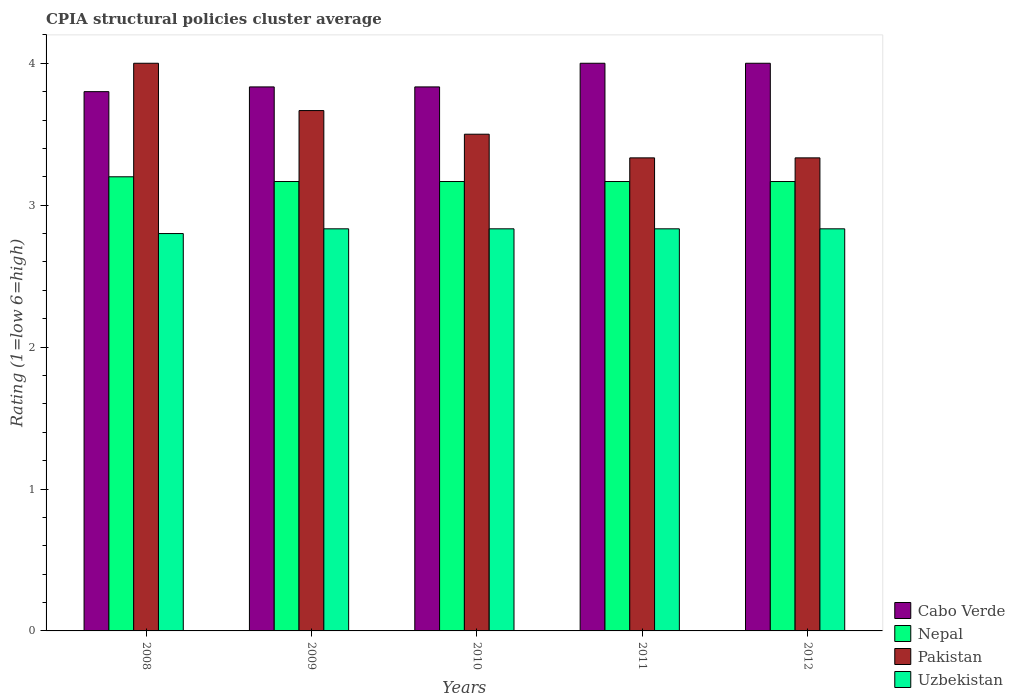How many different coloured bars are there?
Ensure brevity in your answer.  4. How many groups of bars are there?
Offer a terse response. 5. Are the number of bars per tick equal to the number of legend labels?
Keep it short and to the point. Yes. How many bars are there on the 5th tick from the right?
Give a very brief answer. 4. What is the CPIA rating in Uzbekistan in 2008?
Offer a very short reply. 2.8. Across all years, what is the maximum CPIA rating in Uzbekistan?
Ensure brevity in your answer.  2.83. Across all years, what is the minimum CPIA rating in Nepal?
Offer a very short reply. 3.17. In which year was the CPIA rating in Uzbekistan minimum?
Your answer should be compact. 2008. What is the total CPIA rating in Nepal in the graph?
Keep it short and to the point. 15.87. What is the difference between the CPIA rating in Pakistan in 2008 and the CPIA rating in Uzbekistan in 2011?
Keep it short and to the point. 1.17. What is the average CPIA rating in Nepal per year?
Give a very brief answer. 3.17. In the year 2012, what is the difference between the CPIA rating in Nepal and CPIA rating in Cabo Verde?
Offer a very short reply. -0.83. In how many years, is the CPIA rating in Pakistan greater than 0.2?
Give a very brief answer. 5. What is the ratio of the CPIA rating in Pakistan in 2008 to that in 2012?
Offer a very short reply. 1.2. Is the difference between the CPIA rating in Nepal in 2009 and 2011 greater than the difference between the CPIA rating in Cabo Verde in 2009 and 2011?
Offer a very short reply. Yes. What is the difference between the highest and the second highest CPIA rating in Nepal?
Make the answer very short. 0.03. What is the difference between the highest and the lowest CPIA rating in Pakistan?
Make the answer very short. 0.67. In how many years, is the CPIA rating in Nepal greater than the average CPIA rating in Nepal taken over all years?
Offer a very short reply. 1. Is it the case that in every year, the sum of the CPIA rating in Nepal and CPIA rating in Cabo Verde is greater than the sum of CPIA rating in Pakistan and CPIA rating in Uzbekistan?
Offer a terse response. No. What does the 4th bar from the left in 2009 represents?
Offer a very short reply. Uzbekistan. What does the 4th bar from the right in 2010 represents?
Your answer should be compact. Cabo Verde. Are all the bars in the graph horizontal?
Your answer should be compact. No. What is the difference between two consecutive major ticks on the Y-axis?
Keep it short and to the point. 1. Are the values on the major ticks of Y-axis written in scientific E-notation?
Your answer should be very brief. No. Does the graph contain grids?
Provide a short and direct response. No. Where does the legend appear in the graph?
Offer a terse response. Bottom right. How many legend labels are there?
Keep it short and to the point. 4. How are the legend labels stacked?
Provide a succinct answer. Vertical. What is the title of the graph?
Keep it short and to the point. CPIA structural policies cluster average. What is the Rating (1=low 6=high) of Pakistan in 2008?
Provide a succinct answer. 4. What is the Rating (1=low 6=high) of Cabo Verde in 2009?
Provide a short and direct response. 3.83. What is the Rating (1=low 6=high) in Nepal in 2009?
Keep it short and to the point. 3.17. What is the Rating (1=low 6=high) of Pakistan in 2009?
Ensure brevity in your answer.  3.67. What is the Rating (1=low 6=high) in Uzbekistan in 2009?
Provide a short and direct response. 2.83. What is the Rating (1=low 6=high) in Cabo Verde in 2010?
Keep it short and to the point. 3.83. What is the Rating (1=low 6=high) of Nepal in 2010?
Provide a succinct answer. 3.17. What is the Rating (1=low 6=high) in Uzbekistan in 2010?
Offer a terse response. 2.83. What is the Rating (1=low 6=high) in Nepal in 2011?
Keep it short and to the point. 3.17. What is the Rating (1=low 6=high) of Pakistan in 2011?
Ensure brevity in your answer.  3.33. What is the Rating (1=low 6=high) of Uzbekistan in 2011?
Offer a very short reply. 2.83. What is the Rating (1=low 6=high) of Nepal in 2012?
Make the answer very short. 3.17. What is the Rating (1=low 6=high) in Pakistan in 2012?
Offer a terse response. 3.33. What is the Rating (1=low 6=high) in Uzbekistan in 2012?
Make the answer very short. 2.83. Across all years, what is the maximum Rating (1=low 6=high) of Pakistan?
Your answer should be very brief. 4. Across all years, what is the maximum Rating (1=low 6=high) of Uzbekistan?
Provide a succinct answer. 2.83. Across all years, what is the minimum Rating (1=low 6=high) of Nepal?
Provide a short and direct response. 3.17. Across all years, what is the minimum Rating (1=low 6=high) of Pakistan?
Your answer should be very brief. 3.33. What is the total Rating (1=low 6=high) of Cabo Verde in the graph?
Keep it short and to the point. 19.47. What is the total Rating (1=low 6=high) in Nepal in the graph?
Keep it short and to the point. 15.87. What is the total Rating (1=low 6=high) of Pakistan in the graph?
Your answer should be compact. 17.83. What is the total Rating (1=low 6=high) of Uzbekistan in the graph?
Keep it short and to the point. 14.13. What is the difference between the Rating (1=low 6=high) in Cabo Verde in 2008 and that in 2009?
Offer a very short reply. -0.03. What is the difference between the Rating (1=low 6=high) in Nepal in 2008 and that in 2009?
Offer a terse response. 0.03. What is the difference between the Rating (1=low 6=high) of Pakistan in 2008 and that in 2009?
Provide a succinct answer. 0.33. What is the difference between the Rating (1=low 6=high) of Uzbekistan in 2008 and that in 2009?
Provide a short and direct response. -0.03. What is the difference between the Rating (1=low 6=high) of Cabo Verde in 2008 and that in 2010?
Provide a short and direct response. -0.03. What is the difference between the Rating (1=low 6=high) in Nepal in 2008 and that in 2010?
Your answer should be very brief. 0.03. What is the difference between the Rating (1=low 6=high) in Pakistan in 2008 and that in 2010?
Your response must be concise. 0.5. What is the difference between the Rating (1=low 6=high) in Uzbekistan in 2008 and that in 2010?
Make the answer very short. -0.03. What is the difference between the Rating (1=low 6=high) of Cabo Verde in 2008 and that in 2011?
Provide a succinct answer. -0.2. What is the difference between the Rating (1=low 6=high) of Uzbekistan in 2008 and that in 2011?
Make the answer very short. -0.03. What is the difference between the Rating (1=low 6=high) in Uzbekistan in 2008 and that in 2012?
Give a very brief answer. -0.03. What is the difference between the Rating (1=low 6=high) of Cabo Verde in 2009 and that in 2010?
Your response must be concise. 0. What is the difference between the Rating (1=low 6=high) of Pakistan in 2009 and that in 2010?
Your answer should be very brief. 0.17. What is the difference between the Rating (1=low 6=high) of Cabo Verde in 2009 and that in 2011?
Make the answer very short. -0.17. What is the difference between the Rating (1=low 6=high) of Nepal in 2009 and that in 2011?
Offer a terse response. 0. What is the difference between the Rating (1=low 6=high) in Uzbekistan in 2009 and that in 2011?
Your answer should be very brief. 0. What is the difference between the Rating (1=low 6=high) of Uzbekistan in 2009 and that in 2012?
Your answer should be compact. 0. What is the difference between the Rating (1=low 6=high) of Cabo Verde in 2010 and that in 2011?
Your answer should be compact. -0.17. What is the difference between the Rating (1=low 6=high) in Nepal in 2010 and that in 2011?
Make the answer very short. 0. What is the difference between the Rating (1=low 6=high) of Nepal in 2010 and that in 2012?
Ensure brevity in your answer.  0. What is the difference between the Rating (1=low 6=high) in Uzbekistan in 2011 and that in 2012?
Your answer should be very brief. 0. What is the difference between the Rating (1=low 6=high) in Cabo Verde in 2008 and the Rating (1=low 6=high) in Nepal in 2009?
Your answer should be very brief. 0.63. What is the difference between the Rating (1=low 6=high) of Cabo Verde in 2008 and the Rating (1=low 6=high) of Pakistan in 2009?
Offer a very short reply. 0.13. What is the difference between the Rating (1=low 6=high) of Cabo Verde in 2008 and the Rating (1=low 6=high) of Uzbekistan in 2009?
Your answer should be very brief. 0.97. What is the difference between the Rating (1=low 6=high) of Nepal in 2008 and the Rating (1=low 6=high) of Pakistan in 2009?
Provide a succinct answer. -0.47. What is the difference between the Rating (1=low 6=high) in Nepal in 2008 and the Rating (1=low 6=high) in Uzbekistan in 2009?
Offer a terse response. 0.37. What is the difference between the Rating (1=low 6=high) in Cabo Verde in 2008 and the Rating (1=low 6=high) in Nepal in 2010?
Provide a short and direct response. 0.63. What is the difference between the Rating (1=low 6=high) of Cabo Verde in 2008 and the Rating (1=low 6=high) of Uzbekistan in 2010?
Give a very brief answer. 0.97. What is the difference between the Rating (1=low 6=high) of Nepal in 2008 and the Rating (1=low 6=high) of Pakistan in 2010?
Keep it short and to the point. -0.3. What is the difference between the Rating (1=low 6=high) of Nepal in 2008 and the Rating (1=low 6=high) of Uzbekistan in 2010?
Provide a short and direct response. 0.37. What is the difference between the Rating (1=low 6=high) of Pakistan in 2008 and the Rating (1=low 6=high) of Uzbekistan in 2010?
Provide a short and direct response. 1.17. What is the difference between the Rating (1=low 6=high) in Cabo Verde in 2008 and the Rating (1=low 6=high) in Nepal in 2011?
Ensure brevity in your answer.  0.63. What is the difference between the Rating (1=low 6=high) of Cabo Verde in 2008 and the Rating (1=low 6=high) of Pakistan in 2011?
Provide a short and direct response. 0.47. What is the difference between the Rating (1=low 6=high) in Cabo Verde in 2008 and the Rating (1=low 6=high) in Uzbekistan in 2011?
Your answer should be very brief. 0.97. What is the difference between the Rating (1=low 6=high) of Nepal in 2008 and the Rating (1=low 6=high) of Pakistan in 2011?
Your answer should be very brief. -0.13. What is the difference between the Rating (1=low 6=high) in Nepal in 2008 and the Rating (1=low 6=high) in Uzbekistan in 2011?
Your answer should be very brief. 0.37. What is the difference between the Rating (1=low 6=high) of Cabo Verde in 2008 and the Rating (1=low 6=high) of Nepal in 2012?
Provide a succinct answer. 0.63. What is the difference between the Rating (1=low 6=high) of Cabo Verde in 2008 and the Rating (1=low 6=high) of Pakistan in 2012?
Offer a terse response. 0.47. What is the difference between the Rating (1=low 6=high) of Cabo Verde in 2008 and the Rating (1=low 6=high) of Uzbekistan in 2012?
Offer a very short reply. 0.97. What is the difference between the Rating (1=low 6=high) of Nepal in 2008 and the Rating (1=low 6=high) of Pakistan in 2012?
Make the answer very short. -0.13. What is the difference between the Rating (1=low 6=high) in Nepal in 2008 and the Rating (1=low 6=high) in Uzbekistan in 2012?
Your answer should be very brief. 0.37. What is the difference between the Rating (1=low 6=high) of Cabo Verde in 2009 and the Rating (1=low 6=high) of Nepal in 2010?
Keep it short and to the point. 0.67. What is the difference between the Rating (1=low 6=high) in Cabo Verde in 2009 and the Rating (1=low 6=high) in Pakistan in 2010?
Offer a terse response. 0.33. What is the difference between the Rating (1=low 6=high) in Nepal in 2009 and the Rating (1=low 6=high) in Pakistan in 2010?
Provide a succinct answer. -0.33. What is the difference between the Rating (1=low 6=high) in Nepal in 2009 and the Rating (1=low 6=high) in Uzbekistan in 2010?
Keep it short and to the point. 0.33. What is the difference between the Rating (1=low 6=high) in Cabo Verde in 2009 and the Rating (1=low 6=high) in Pakistan in 2011?
Your response must be concise. 0.5. What is the difference between the Rating (1=low 6=high) of Cabo Verde in 2009 and the Rating (1=low 6=high) of Uzbekistan in 2011?
Make the answer very short. 1. What is the difference between the Rating (1=low 6=high) in Nepal in 2009 and the Rating (1=low 6=high) in Pakistan in 2011?
Give a very brief answer. -0.17. What is the difference between the Rating (1=low 6=high) in Cabo Verde in 2009 and the Rating (1=low 6=high) in Nepal in 2012?
Keep it short and to the point. 0.67. What is the difference between the Rating (1=low 6=high) in Cabo Verde in 2009 and the Rating (1=low 6=high) in Pakistan in 2012?
Offer a terse response. 0.5. What is the difference between the Rating (1=low 6=high) of Nepal in 2009 and the Rating (1=low 6=high) of Pakistan in 2012?
Your answer should be very brief. -0.17. What is the difference between the Rating (1=low 6=high) in Cabo Verde in 2010 and the Rating (1=low 6=high) in Nepal in 2011?
Keep it short and to the point. 0.67. What is the difference between the Rating (1=low 6=high) of Cabo Verde in 2010 and the Rating (1=low 6=high) of Pakistan in 2011?
Your answer should be compact. 0.5. What is the difference between the Rating (1=low 6=high) in Cabo Verde in 2010 and the Rating (1=low 6=high) in Uzbekistan in 2011?
Keep it short and to the point. 1. What is the difference between the Rating (1=low 6=high) of Pakistan in 2010 and the Rating (1=low 6=high) of Uzbekistan in 2011?
Keep it short and to the point. 0.67. What is the difference between the Rating (1=low 6=high) of Cabo Verde in 2010 and the Rating (1=low 6=high) of Pakistan in 2012?
Ensure brevity in your answer.  0.5. What is the difference between the Rating (1=low 6=high) in Cabo Verde in 2010 and the Rating (1=low 6=high) in Uzbekistan in 2012?
Your answer should be very brief. 1. What is the difference between the Rating (1=low 6=high) in Nepal in 2010 and the Rating (1=low 6=high) in Pakistan in 2012?
Ensure brevity in your answer.  -0.17. What is the difference between the Rating (1=low 6=high) in Pakistan in 2010 and the Rating (1=low 6=high) in Uzbekistan in 2012?
Your answer should be compact. 0.67. What is the difference between the Rating (1=low 6=high) in Cabo Verde in 2011 and the Rating (1=low 6=high) in Pakistan in 2012?
Give a very brief answer. 0.67. What is the difference between the Rating (1=low 6=high) in Cabo Verde in 2011 and the Rating (1=low 6=high) in Uzbekistan in 2012?
Make the answer very short. 1.17. What is the average Rating (1=low 6=high) of Cabo Verde per year?
Offer a terse response. 3.89. What is the average Rating (1=low 6=high) in Nepal per year?
Make the answer very short. 3.17. What is the average Rating (1=low 6=high) of Pakistan per year?
Offer a terse response. 3.57. What is the average Rating (1=low 6=high) in Uzbekistan per year?
Make the answer very short. 2.83. In the year 2008, what is the difference between the Rating (1=low 6=high) in Cabo Verde and Rating (1=low 6=high) in Nepal?
Give a very brief answer. 0.6. In the year 2008, what is the difference between the Rating (1=low 6=high) of Cabo Verde and Rating (1=low 6=high) of Uzbekistan?
Ensure brevity in your answer.  1. In the year 2008, what is the difference between the Rating (1=low 6=high) of Nepal and Rating (1=low 6=high) of Pakistan?
Keep it short and to the point. -0.8. In the year 2009, what is the difference between the Rating (1=low 6=high) of Cabo Verde and Rating (1=low 6=high) of Nepal?
Your answer should be very brief. 0.67. In the year 2009, what is the difference between the Rating (1=low 6=high) of Cabo Verde and Rating (1=low 6=high) of Pakistan?
Provide a succinct answer. 0.17. In the year 2009, what is the difference between the Rating (1=low 6=high) of Cabo Verde and Rating (1=low 6=high) of Uzbekistan?
Provide a short and direct response. 1. In the year 2009, what is the difference between the Rating (1=low 6=high) of Nepal and Rating (1=low 6=high) of Pakistan?
Keep it short and to the point. -0.5. In the year 2009, what is the difference between the Rating (1=low 6=high) of Nepal and Rating (1=low 6=high) of Uzbekistan?
Your response must be concise. 0.33. In the year 2009, what is the difference between the Rating (1=low 6=high) in Pakistan and Rating (1=low 6=high) in Uzbekistan?
Provide a short and direct response. 0.83. In the year 2010, what is the difference between the Rating (1=low 6=high) in Cabo Verde and Rating (1=low 6=high) in Nepal?
Offer a terse response. 0.67. In the year 2010, what is the difference between the Rating (1=low 6=high) of Cabo Verde and Rating (1=low 6=high) of Uzbekistan?
Ensure brevity in your answer.  1. In the year 2011, what is the difference between the Rating (1=low 6=high) in Cabo Verde and Rating (1=low 6=high) in Pakistan?
Your answer should be compact. 0.67. In the year 2011, what is the difference between the Rating (1=low 6=high) in Cabo Verde and Rating (1=low 6=high) in Uzbekistan?
Offer a very short reply. 1.17. In the year 2011, what is the difference between the Rating (1=low 6=high) in Nepal and Rating (1=low 6=high) in Pakistan?
Provide a short and direct response. -0.17. In the year 2011, what is the difference between the Rating (1=low 6=high) of Nepal and Rating (1=low 6=high) of Uzbekistan?
Your answer should be compact. 0.33. In the year 2011, what is the difference between the Rating (1=low 6=high) in Pakistan and Rating (1=low 6=high) in Uzbekistan?
Give a very brief answer. 0.5. In the year 2012, what is the difference between the Rating (1=low 6=high) in Cabo Verde and Rating (1=low 6=high) in Nepal?
Offer a very short reply. 0.83. In the year 2012, what is the difference between the Rating (1=low 6=high) of Cabo Verde and Rating (1=low 6=high) of Pakistan?
Your answer should be compact. 0.67. In the year 2012, what is the difference between the Rating (1=low 6=high) in Cabo Verde and Rating (1=low 6=high) in Uzbekistan?
Your response must be concise. 1.17. In the year 2012, what is the difference between the Rating (1=low 6=high) in Pakistan and Rating (1=low 6=high) in Uzbekistan?
Provide a succinct answer. 0.5. What is the ratio of the Rating (1=low 6=high) of Nepal in 2008 to that in 2009?
Offer a terse response. 1.01. What is the ratio of the Rating (1=low 6=high) of Uzbekistan in 2008 to that in 2009?
Your answer should be compact. 0.99. What is the ratio of the Rating (1=low 6=high) in Cabo Verde in 2008 to that in 2010?
Keep it short and to the point. 0.99. What is the ratio of the Rating (1=low 6=high) in Nepal in 2008 to that in 2010?
Offer a very short reply. 1.01. What is the ratio of the Rating (1=low 6=high) of Nepal in 2008 to that in 2011?
Keep it short and to the point. 1.01. What is the ratio of the Rating (1=low 6=high) in Pakistan in 2008 to that in 2011?
Keep it short and to the point. 1.2. What is the ratio of the Rating (1=low 6=high) of Uzbekistan in 2008 to that in 2011?
Your answer should be compact. 0.99. What is the ratio of the Rating (1=low 6=high) of Cabo Verde in 2008 to that in 2012?
Provide a short and direct response. 0.95. What is the ratio of the Rating (1=low 6=high) in Nepal in 2008 to that in 2012?
Keep it short and to the point. 1.01. What is the ratio of the Rating (1=low 6=high) in Uzbekistan in 2008 to that in 2012?
Make the answer very short. 0.99. What is the ratio of the Rating (1=low 6=high) in Nepal in 2009 to that in 2010?
Ensure brevity in your answer.  1. What is the ratio of the Rating (1=low 6=high) of Pakistan in 2009 to that in 2010?
Ensure brevity in your answer.  1.05. What is the ratio of the Rating (1=low 6=high) in Cabo Verde in 2009 to that in 2011?
Keep it short and to the point. 0.96. What is the ratio of the Rating (1=low 6=high) in Cabo Verde in 2010 to that in 2011?
Your answer should be very brief. 0.96. What is the ratio of the Rating (1=low 6=high) of Uzbekistan in 2010 to that in 2012?
Provide a short and direct response. 1. What is the ratio of the Rating (1=low 6=high) in Cabo Verde in 2011 to that in 2012?
Keep it short and to the point. 1. What is the ratio of the Rating (1=low 6=high) of Nepal in 2011 to that in 2012?
Your response must be concise. 1. What is the ratio of the Rating (1=low 6=high) of Uzbekistan in 2011 to that in 2012?
Provide a short and direct response. 1. What is the difference between the highest and the second highest Rating (1=low 6=high) in Pakistan?
Make the answer very short. 0.33. What is the difference between the highest and the lowest Rating (1=low 6=high) in Cabo Verde?
Your response must be concise. 0.2. What is the difference between the highest and the lowest Rating (1=low 6=high) in Uzbekistan?
Provide a short and direct response. 0.03. 